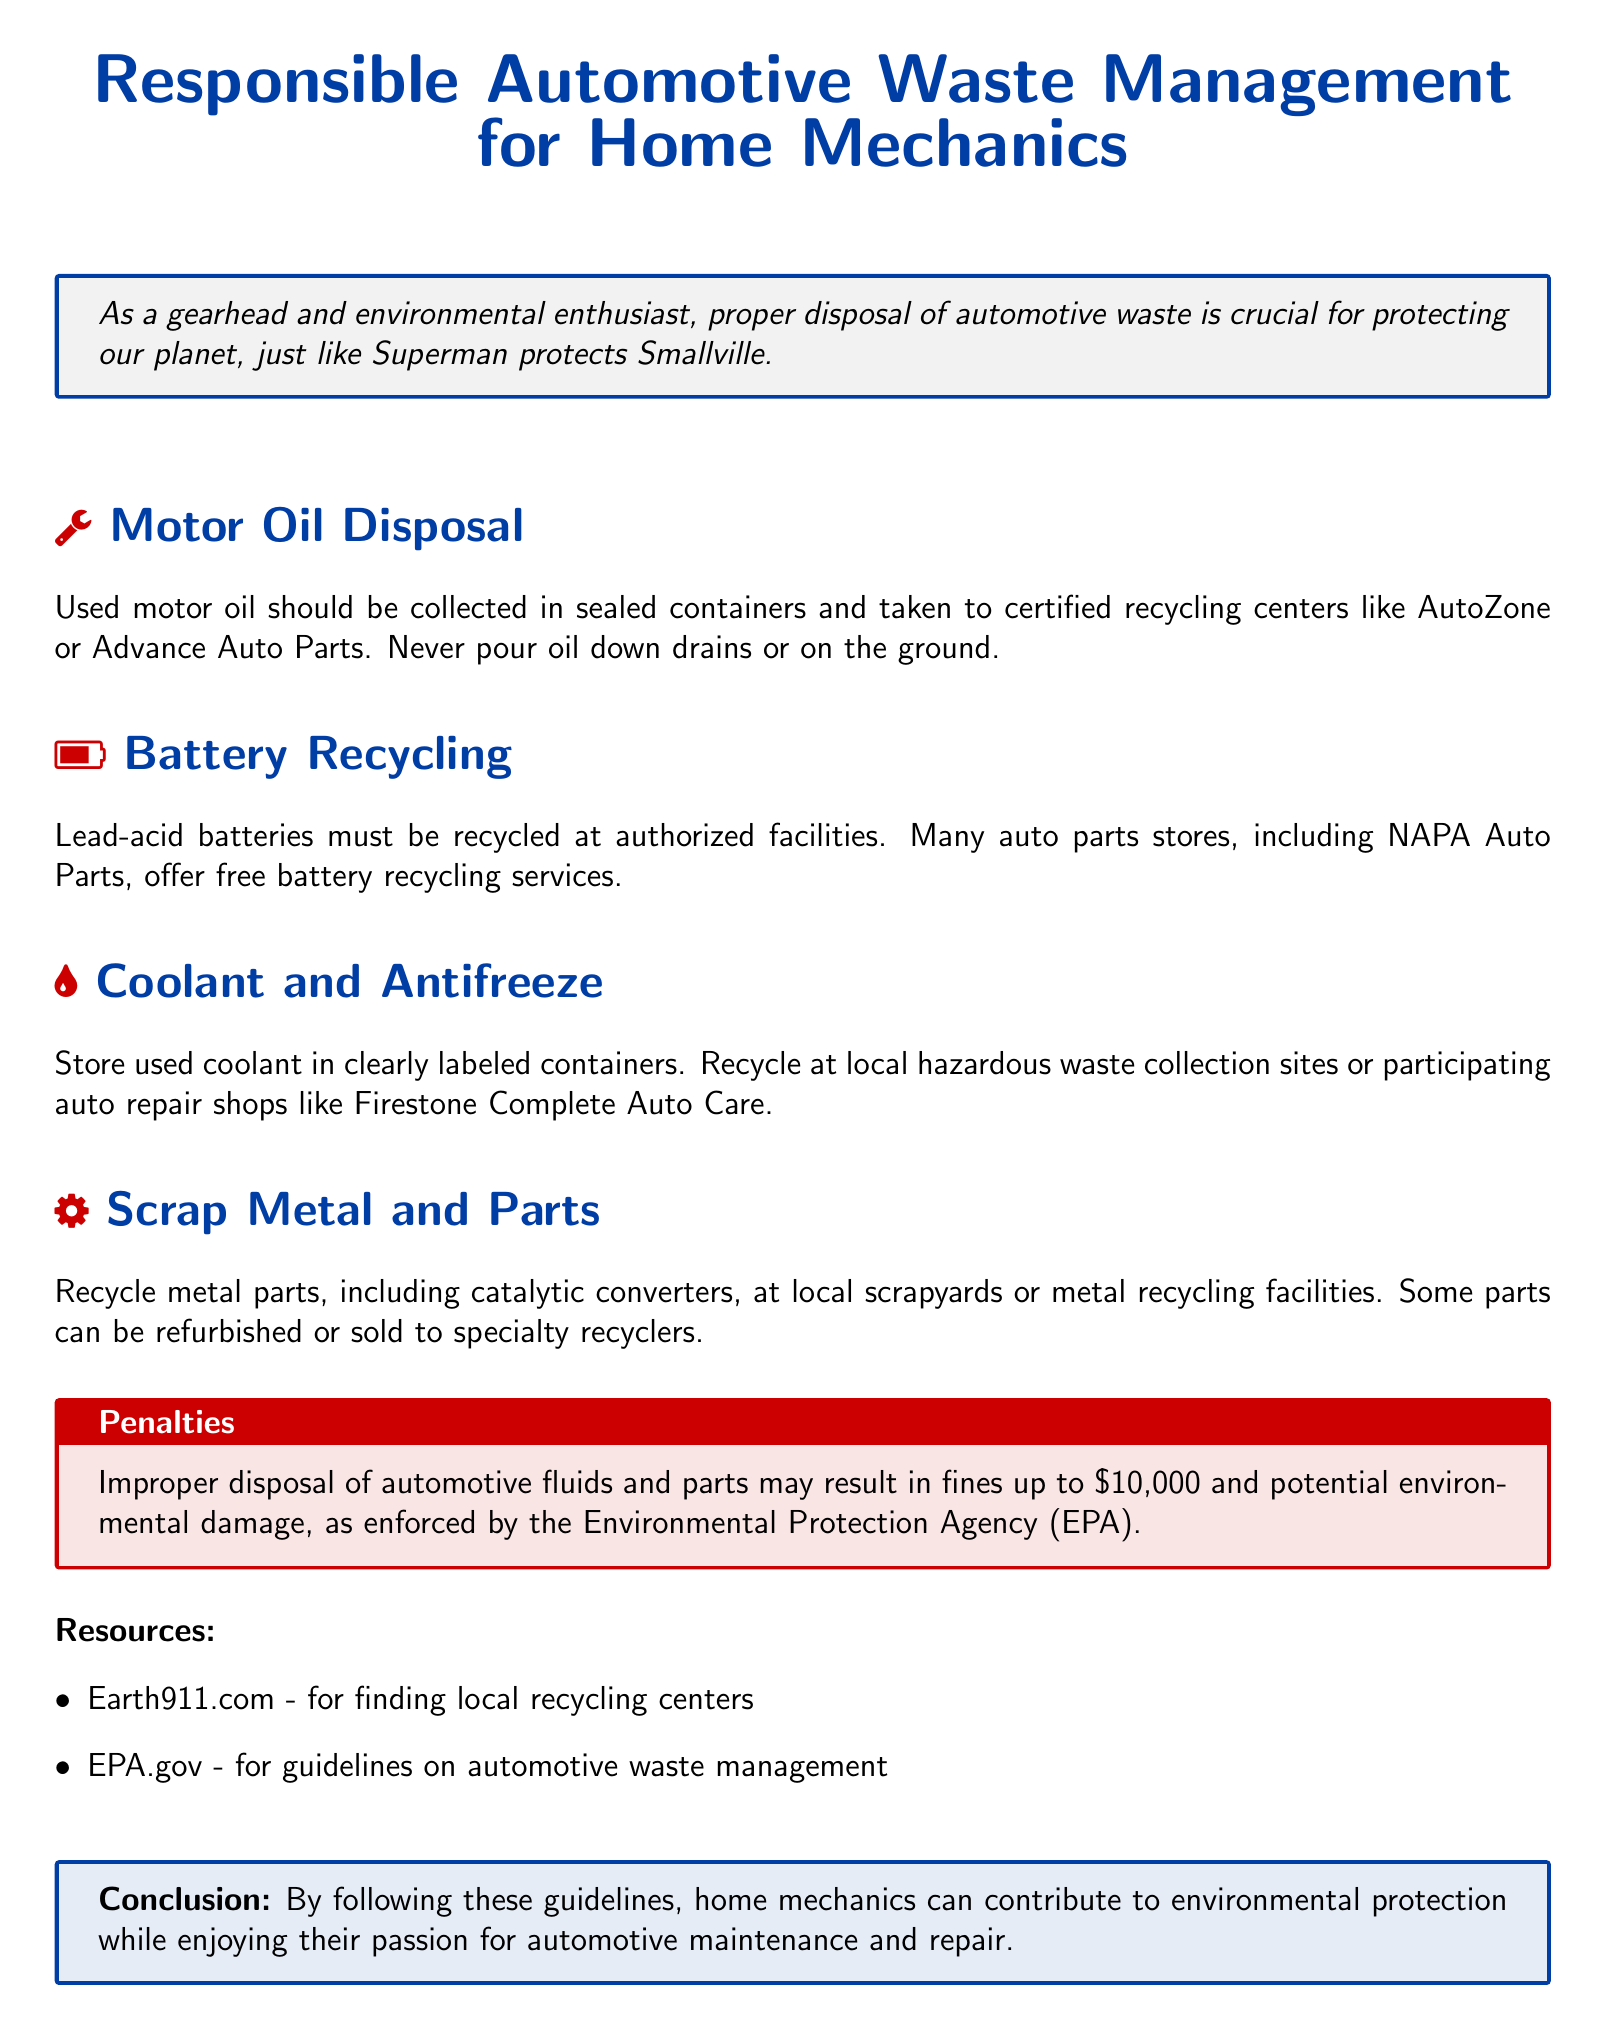What should used motor oil be stored in? The document states used motor oil should be collected in sealed containers.
Answer: Sealed containers Where can used motor oil be recycled? The document mentions certified recycling centers such as AutoZone or Advance Auto Parts.
Answer: AutoZone or Advance Auto Parts What type of batteries must be recycled? The document specifies lead-acid batteries must be recycled.
Answer: Lead-acid batteries What are the penalties for improper disposal of automotive fluids? The document states fines up to $10,000 are possible for improper disposal.
Answer: $10,000 Which store offers free battery recycling services? The document lists NAPA Auto Parts as a store that offers free battery recycling.
Answer: NAPA Auto Parts What should you do with used coolant? The document advises to store used coolant in clearly labeled containers.
Answer: Clearly labeled containers Where can you find local recycling centers? The document provides Earth911.com as a resource for finding local recycling centers.
Answer: Earth911.com What is the maximum penalty for improper disposal according to the EPA? The document mentions potential fines up to $10,000 enforced by the EPA.
Answer: $10,000 